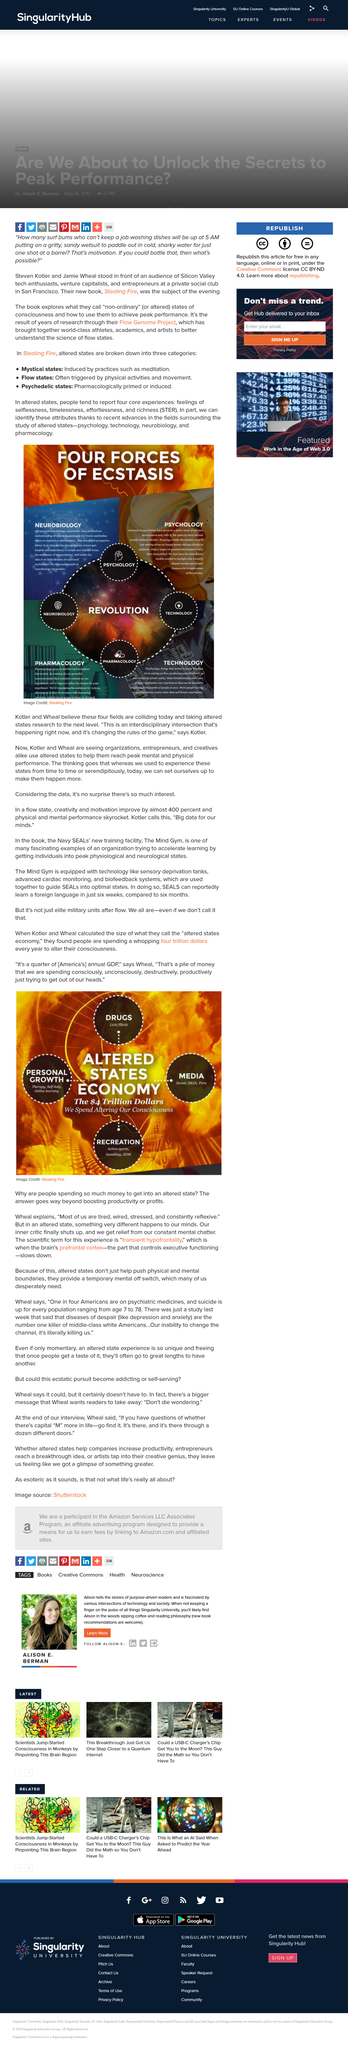Indicate a few pertinent items in this graphic. The four forces of ecstasis are neurobiology, pharmacology, technology, and psychology. Altered states can be characterized by four core experiences: a sense of selflessness, timelessness, effortlessness, and richness. Yes, the Mind Gym is equipped with biofeedback systems. Yes, the Mind Gym is equipped with advanced cardiac monitoring technology. The three categories of altered states in "Stealing Fire" are mystical, flow, and psychedelic, which are described as experiences that offer transformative benefits for individuals and organizations. 